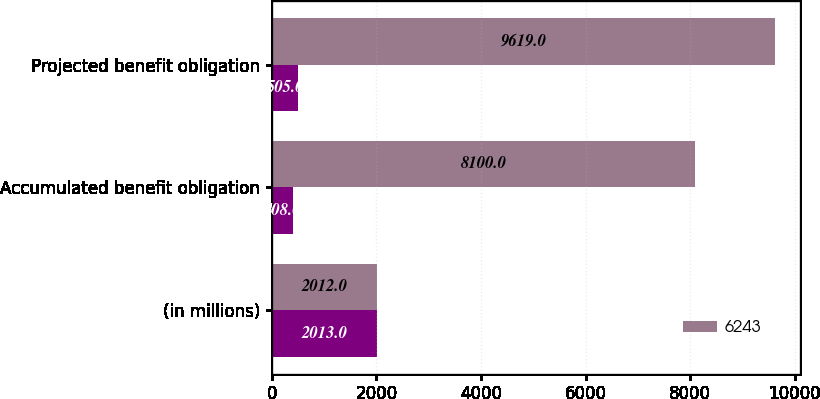Convert chart. <chart><loc_0><loc_0><loc_500><loc_500><stacked_bar_chart><ecel><fcel>(in millions)<fcel>Accumulated benefit obligation<fcel>Projected benefit obligation<nl><fcel>nan<fcel>2013<fcel>408<fcel>505<nl><fcel>6243<fcel>2012<fcel>8100<fcel>9619<nl></chart> 